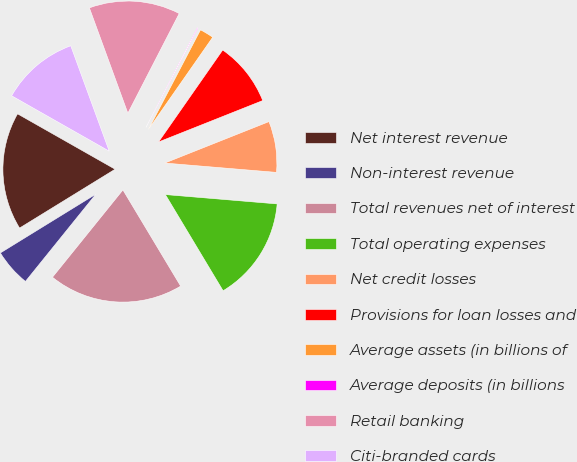<chart> <loc_0><loc_0><loc_500><loc_500><pie_chart><fcel>Net interest revenue<fcel>Non-interest revenue<fcel>Total revenues net of interest<fcel>Total operating expenses<fcel>Net credit losses<fcel>Provisions for loan losses and<fcel>Average assets (in billions of<fcel>Average deposits (in billions<fcel>Retail banking<fcel>Citi-branded cards<nl><fcel>17.0%<fcel>5.41%<fcel>19.41%<fcel>15.07%<fcel>7.35%<fcel>9.28%<fcel>2.03%<fcel>0.1%<fcel>13.14%<fcel>11.21%<nl></chart> 